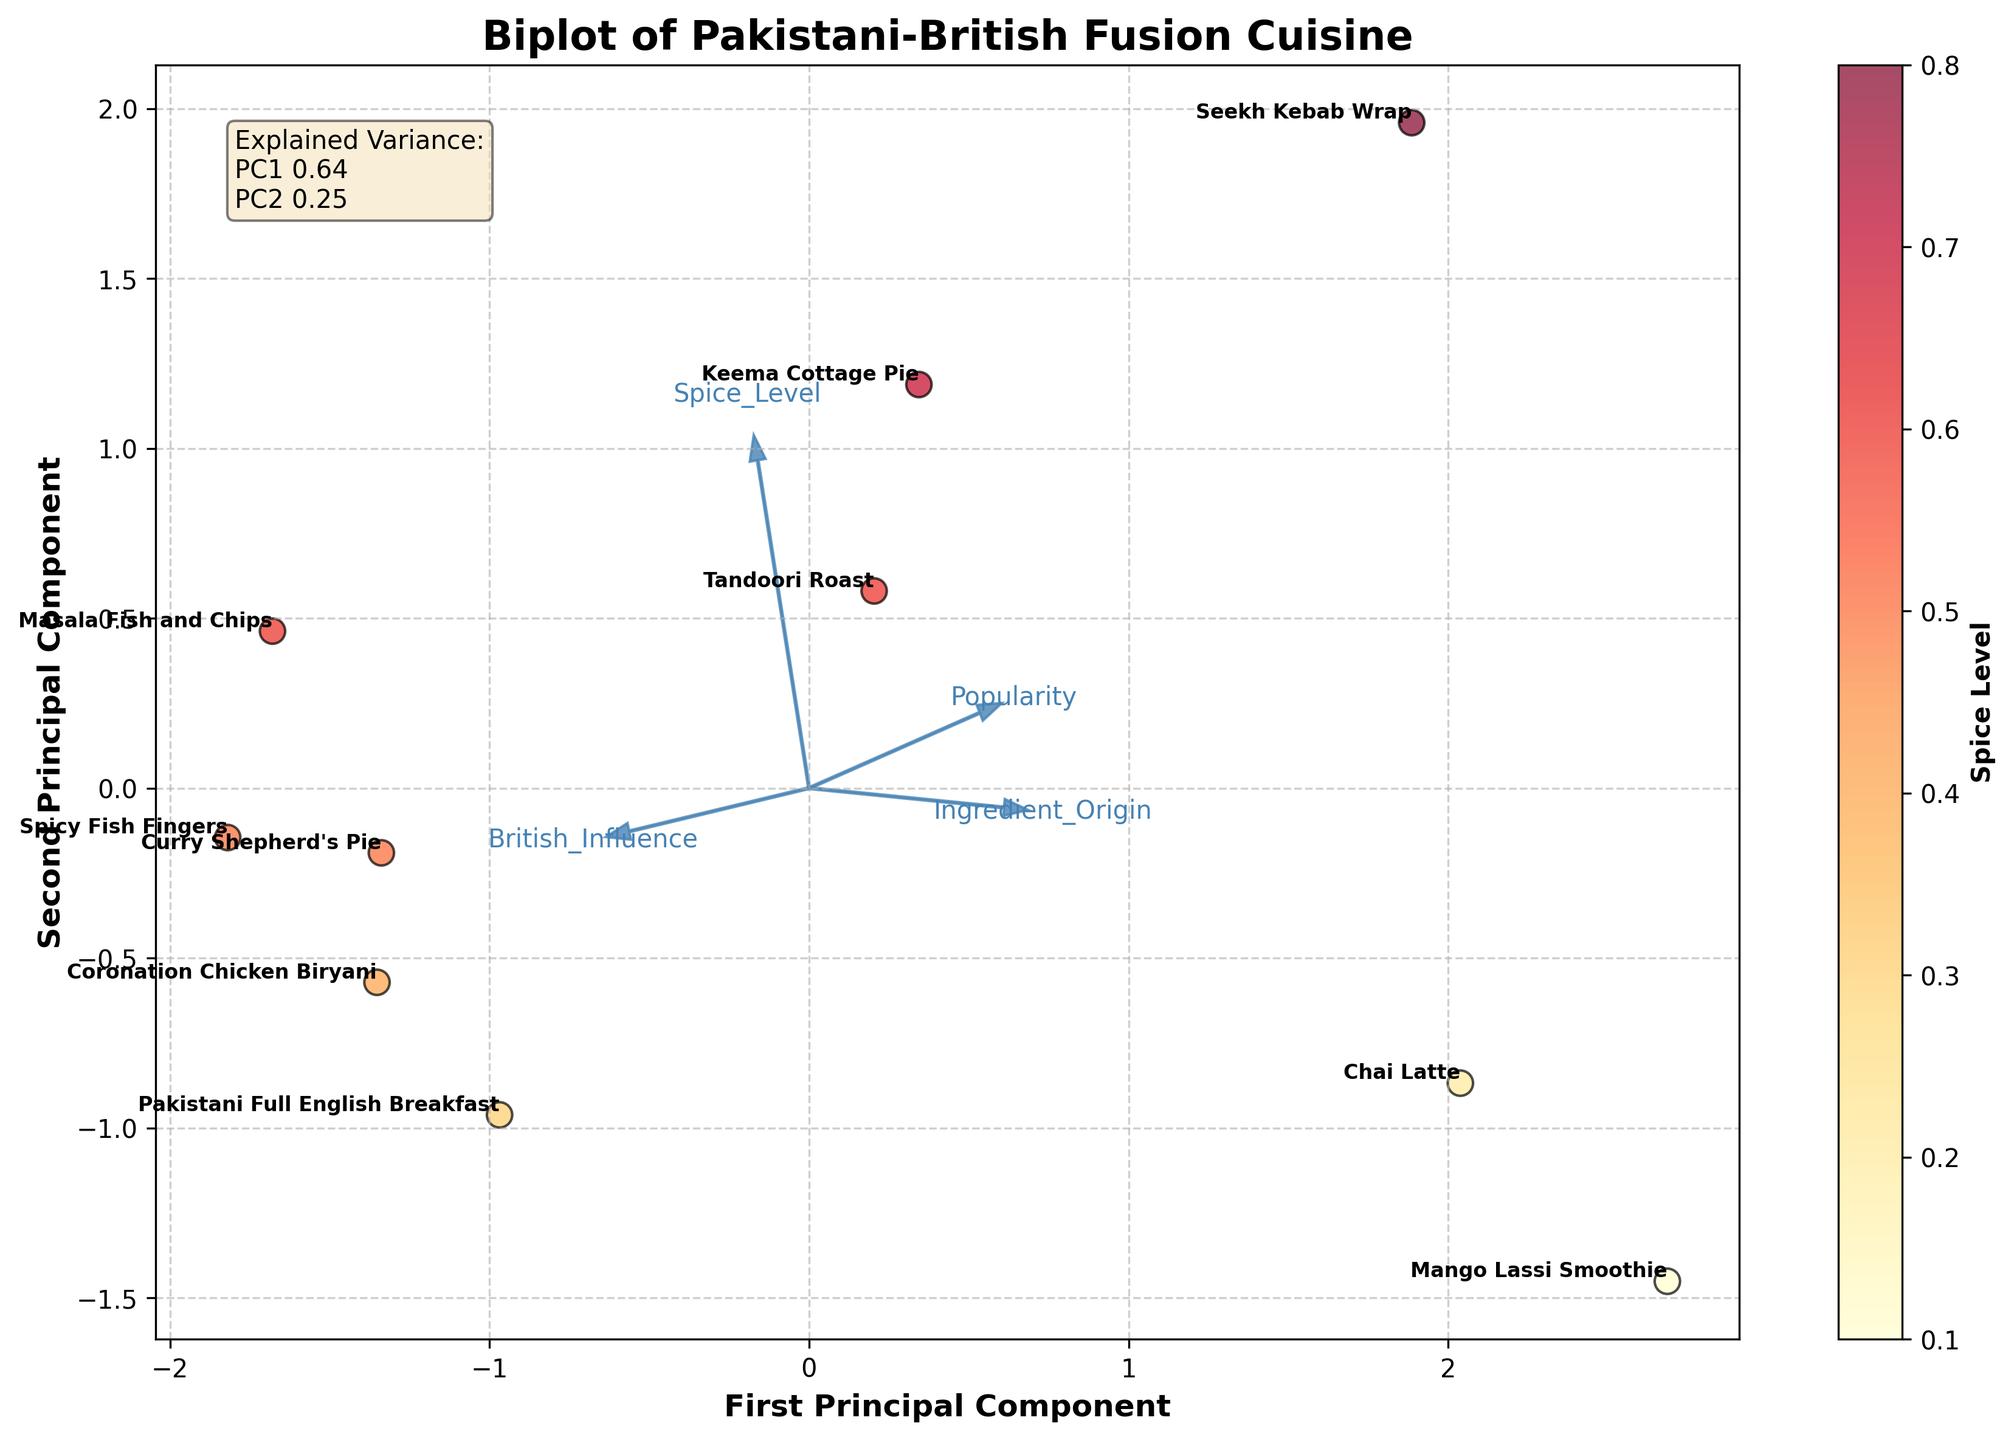What are the axes labeled as? The x-axis represents the "First Principal Component," and the y-axis represents the "Second Principal Component." These components are derived from PCA and indicate the direction of maximum variance in the data.
Answer: First Principal Component (x-axis), Second Principal Component (y-axis) How many dishes are labeled in the figure? There are 10 dishes labeled. Each dish is represented by its name and plotted based on its PCA result.
Answer: 10 Which dish has the highest spice level according to the color scheme? "Seekh Kebab Wrap" has the highest spice level. In the color scheme, it appears to be the warmest color, indicating a high spice level.
Answer: Seekh Kebab Wrap Between "Masala Fish and Chips" and "Pakistani Full English Breakfast," which dish has a higher British influence? "Pakistani Full English Breakfast" has a higher British influence. This is interpreted from its position relative to the feature vector representing "British_Influence."
Answer: Pakistani Full English Breakfast Which dish is closest to the origin (0,0) in the PCA plot? "Chai Latte" is closest to the origin. Its coordinates in the PCA plot place it near the center, indicating less variation from the origin.
Answer: Chai Latte What are the explained variance ratios for the first and second principal components? The variance explained by the first principal component (PC1) is 0.47, and for the second principal component (PC2), it is 0.36. These values are provided as text within the plot.
Answer: 0.47 (PC1), 0.36 (PC2) Compare the "Curry Shepherd's Pie" and "Coronation Chicken Biryani" based on their PCA coordinates. Which dish is more influenced by the first principal component? "Coronation Chicken Biryani" is more influenced by the first principal component as it is farther along the x-axis, which represents PC1, compared to "Curry Shepherd's Pie."
Answer: Coronation Chicken Biryani How is the ingredient origin of dishes represented in the plot? The ingredient origin of dishes is represented by a feature vector in the plot, showing the direction and magnitude similar to other features. It helps indicate how strongly each dish is influenced by the ingredient origin.
Answer: Feature vector Which dish has the lowest spice level, and how can you tell? "Mango Lassi Smoothie" has the lowest spice level. It appears in the lightest color according to the color bar representing spice levels.
Answer: Mango Lassi Smoothie Are there any dishes that have almost equal influence from British culture and spice level? "Tandoori Roast" has an almost equal influence from both British culture and spice level, as it is positioned similarly along the British_Influence and Spice_Level vectors in the PCA plot.
Answer: Tandoori Roast 